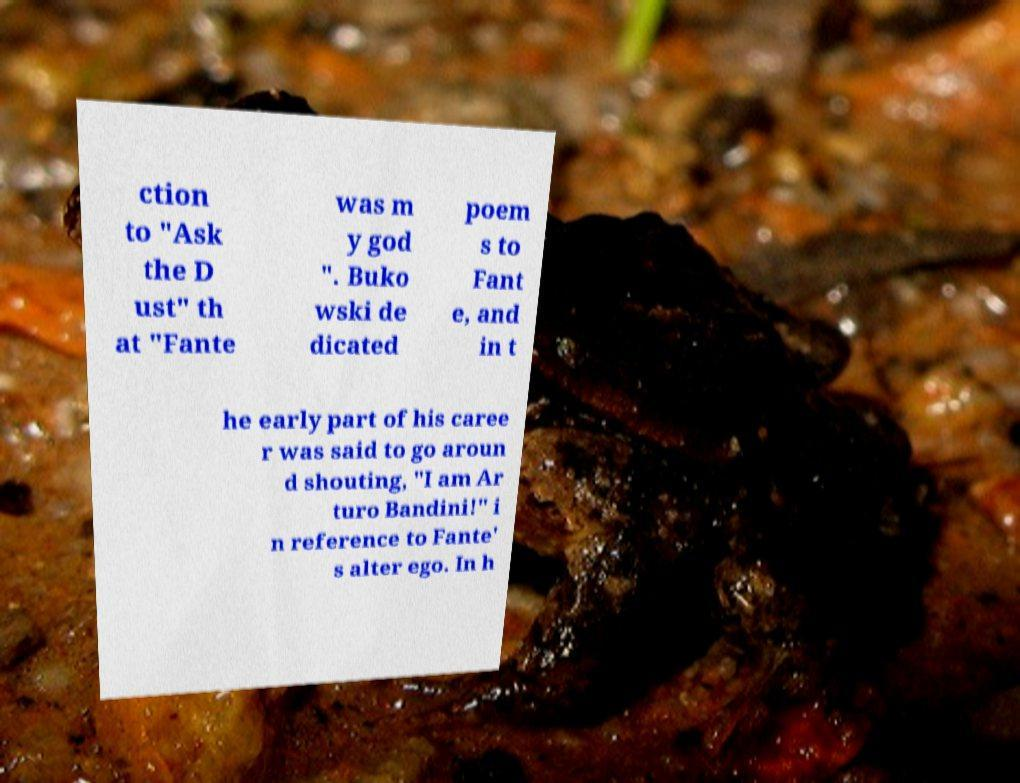Could you assist in decoding the text presented in this image and type it out clearly? ction to "Ask the D ust" th at "Fante was m y god ". Buko wski de dicated poem s to Fant e, and in t he early part of his caree r was said to go aroun d shouting, "I am Ar turo Bandini!" i n reference to Fante' s alter ego. In h 